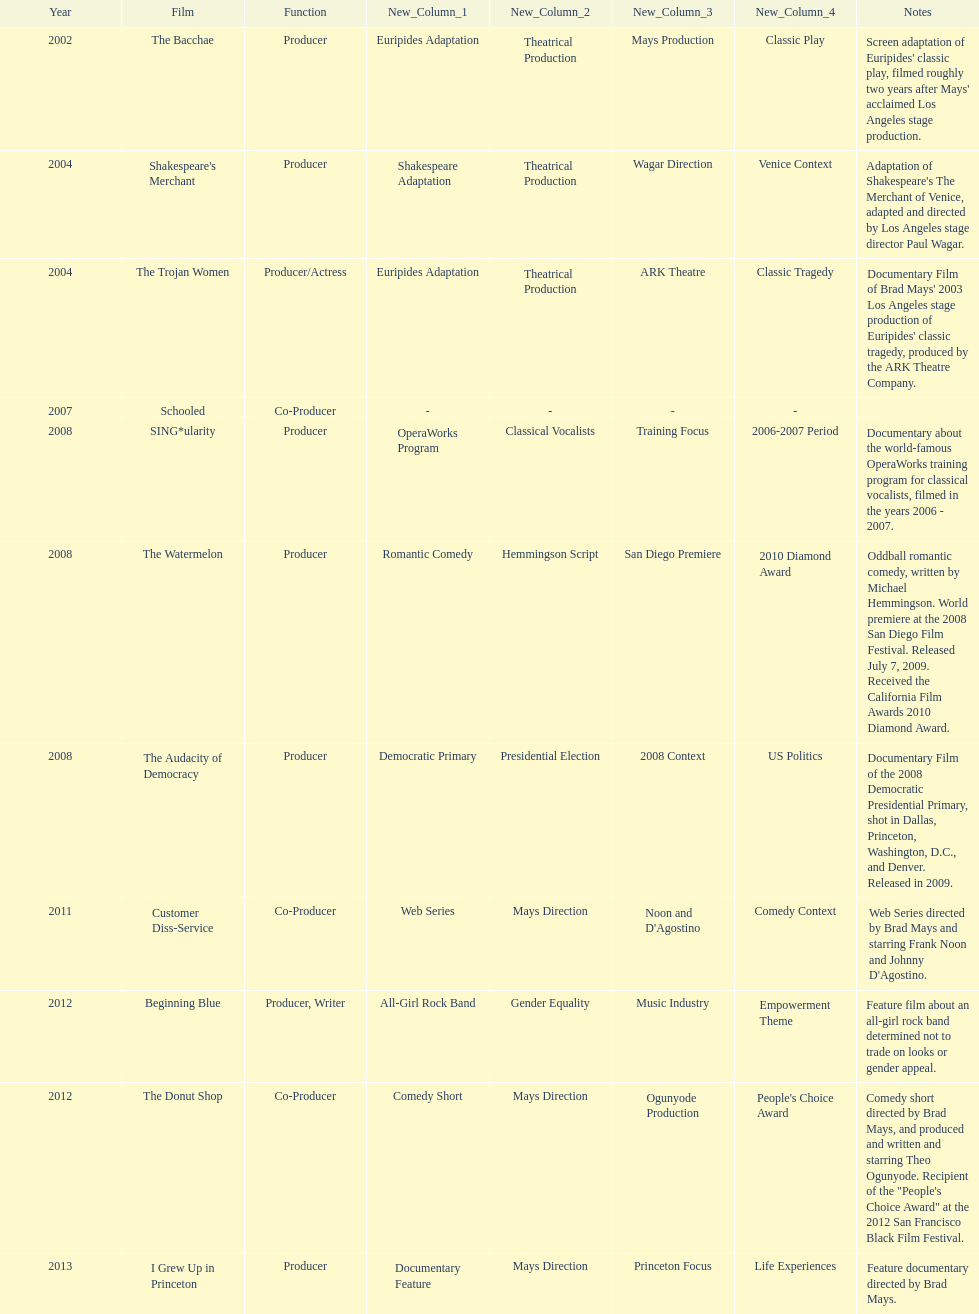Which year was there at least three movies? 2008. 